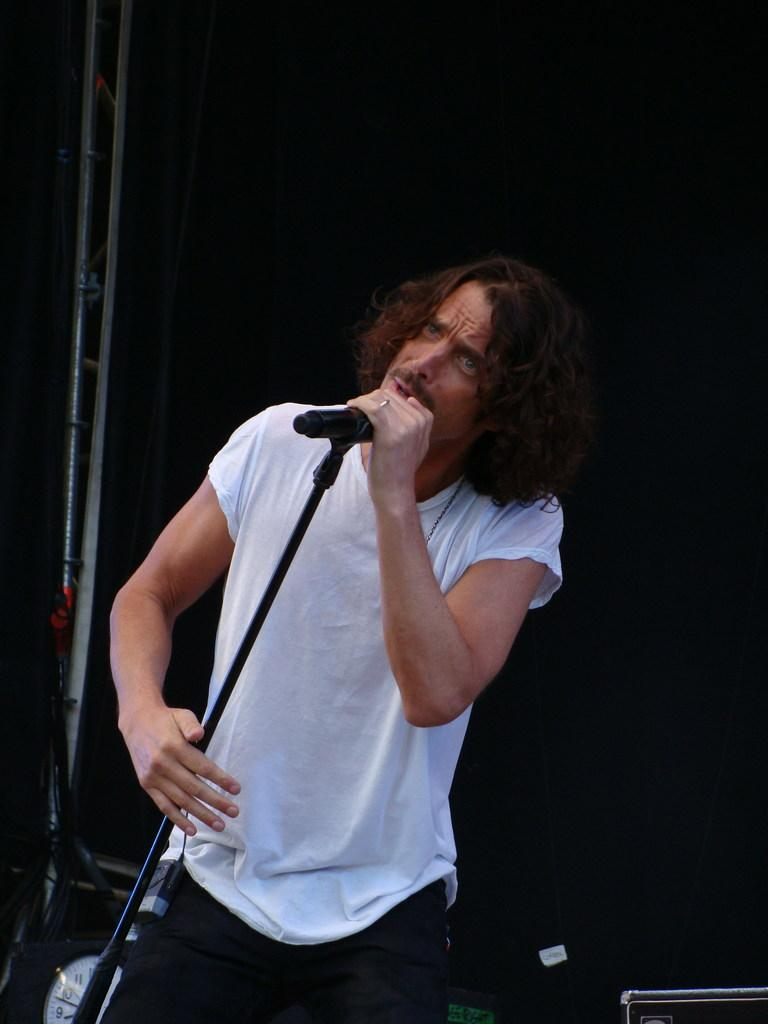What is the man in the image doing? The man is singing on a microphone. What is the man wearing in the image? The man is wearing a white shirt. Can you identify any other objects in the image? Yes, there is a clock visible in the image. What type of observation can be made about the writer in the image? There is no writer present in the image. How does the brake function in the image? There is no brake present in the image. 